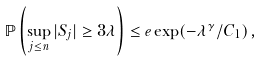Convert formula to latex. <formula><loc_0><loc_0><loc_500><loc_500>\mathbb { P } \left ( \sup _ { j \leq n } | S _ { j } | \geq 3 \lambda \right ) \leq e \exp ( - \lambda ^ { \gamma } / C _ { 1 } ) \, ,</formula> 